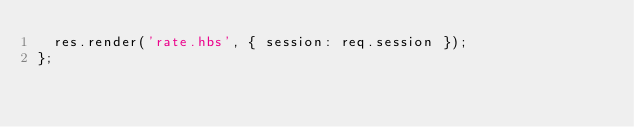Convert code to text. <code><loc_0><loc_0><loc_500><loc_500><_JavaScript_>  res.render('rate.hbs', { session: req.session });
};
</code> 